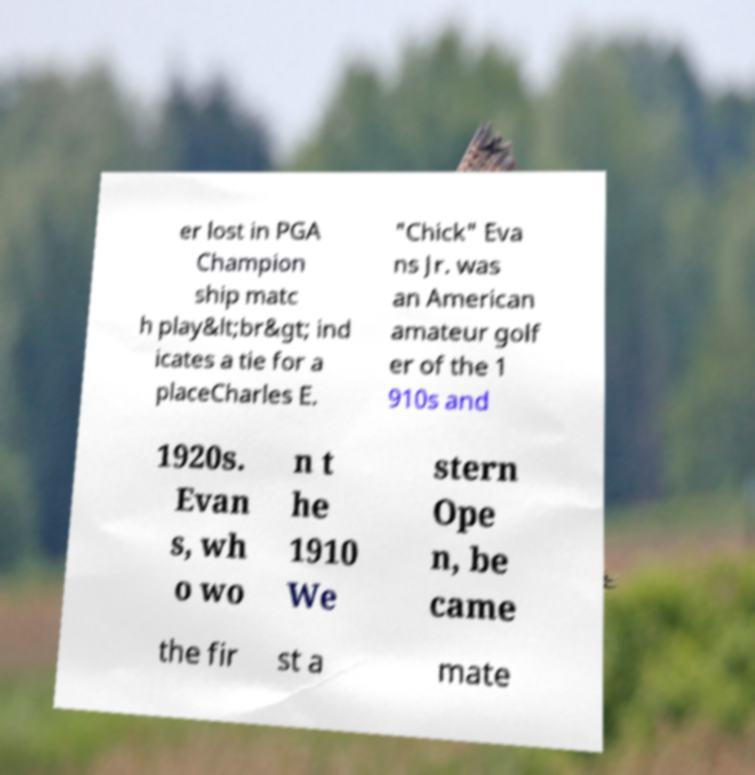What messages or text are displayed in this image? I need them in a readable, typed format. er lost in PGA Champion ship matc h play&lt;br&gt; ind icates a tie for a placeCharles E. "Chick" Eva ns Jr. was an American amateur golf er of the 1 910s and 1920s. Evan s, wh o wo n t he 1910 We stern Ope n, be came the fir st a mate 